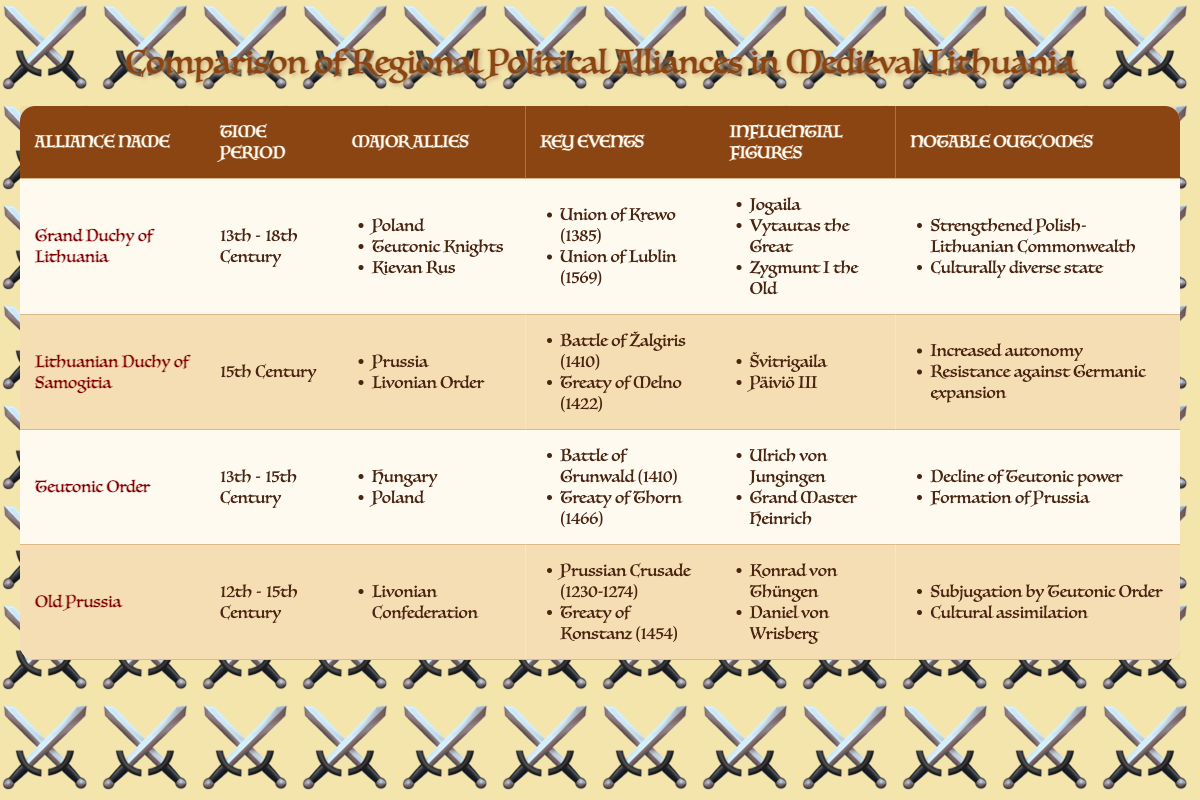What were the major allies of the Grand Duchy of Lithuania? The Grand Duchy of Lithuania's major allies are listed in the table under the "Major Allies" column. They include Poland, Teutonic Knights, and Kievan Rus.
Answer: Poland, Teutonic Knights, Kievan Rus Which alliance was active during the 15th century? The only regional alliance that was documented as being active during the 15th century in the table is the Lithuanian Duchy of Samogitia, as noted in its "Time Period" entry.
Answer: Lithuanian Duchy of Samogitia Was the Teutonic Order's power declining during its existence? Yes, the table indicates that one of the notable outcomes of the Teutonic Order was the "Decline of Teutonic power," confirming that its influence waned during its time.
Answer: Yes How many key events are listed for the Lithuanian Duchy of Samogitia? The table shows that the Lithuanian Duchy of Samogitia has two key events listed under the "Key Events" column: the Battle of Žalgiris (1410) and the Treaty of Melno (1422).
Answer: 2 What significant event in the Grand Duchy of Lithuania occurred in 1569? The Union of Lublin, which took place in 1569, is mentioned in the "Key Events" column under the Grand Duchy of Lithuania, indicating it was a significant occurrence during that period.
Answer: Union of Lublin Which influential figures are shared between the Grand Duchy of Lithuania and the Teutonic Order? To identify shared influential figures, check the "Influential Figures" columns of both alliances. The Grand Duchy of Lithuania features figures like Jogaila, Vytautas the Great, and Zygmunt I the Old, while the Teutonic Order features Ulrich von Jungingen and Grand Master Heinrich. There are no shared figures listed in the table.
Answer: None What was the notable outcome of the Lithuanian Duchy of Samogitia? The notable outcomes listed for the Lithuanian Duchy of Samogitia are "Increased autonomy" and "Resistance against Germanic expansion," which provide insights into its significance during that time.
Answer: Increased autonomy; Resistance against Germanic expansion Which alliances had key events that occurred in 1410? By examining the "Key Events" columns, it is noted that both the Grand Duchy of Lithuania and the Teutonic Order reference events from 1410: the Union of Krewo (Grand Duchy of Lithuania) and the Battle of Grunwald (Teutonic Order).
Answer: Grand Duchy of Lithuania; Teutonic Order How many influential figures are related to the Old Prussia? The table lists two influential figures related to Old Prussia under the "Influential Figures" column: Konrad von Thüngen and Daniel von Wrisberg, indicating a concise number of notable leaders from that region.
Answer: 2 